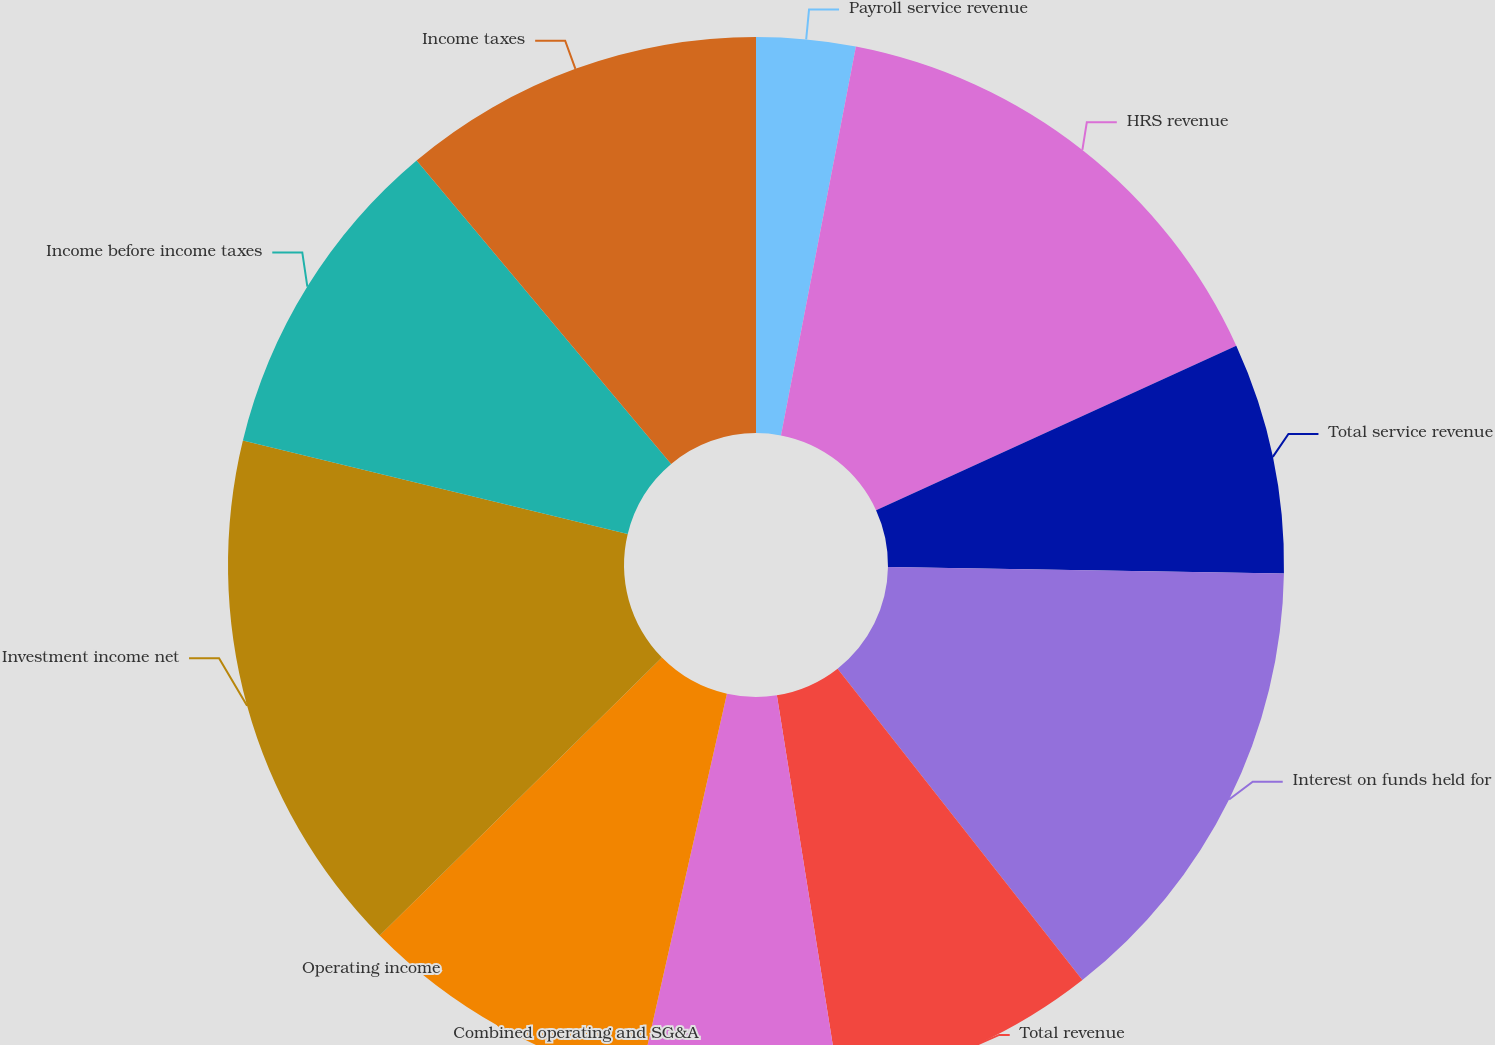Convert chart to OTSL. <chart><loc_0><loc_0><loc_500><loc_500><pie_chart><fcel>Payroll service revenue<fcel>HRS revenue<fcel>Total service revenue<fcel>Interest on funds held for<fcel>Total revenue<fcel>Combined operating and SG&A<fcel>Operating income<fcel>Investment income net<fcel>Income before income taxes<fcel>Income taxes<nl><fcel>3.03%<fcel>15.15%<fcel>7.07%<fcel>14.14%<fcel>8.08%<fcel>6.06%<fcel>9.09%<fcel>16.16%<fcel>10.1%<fcel>11.11%<nl></chart> 